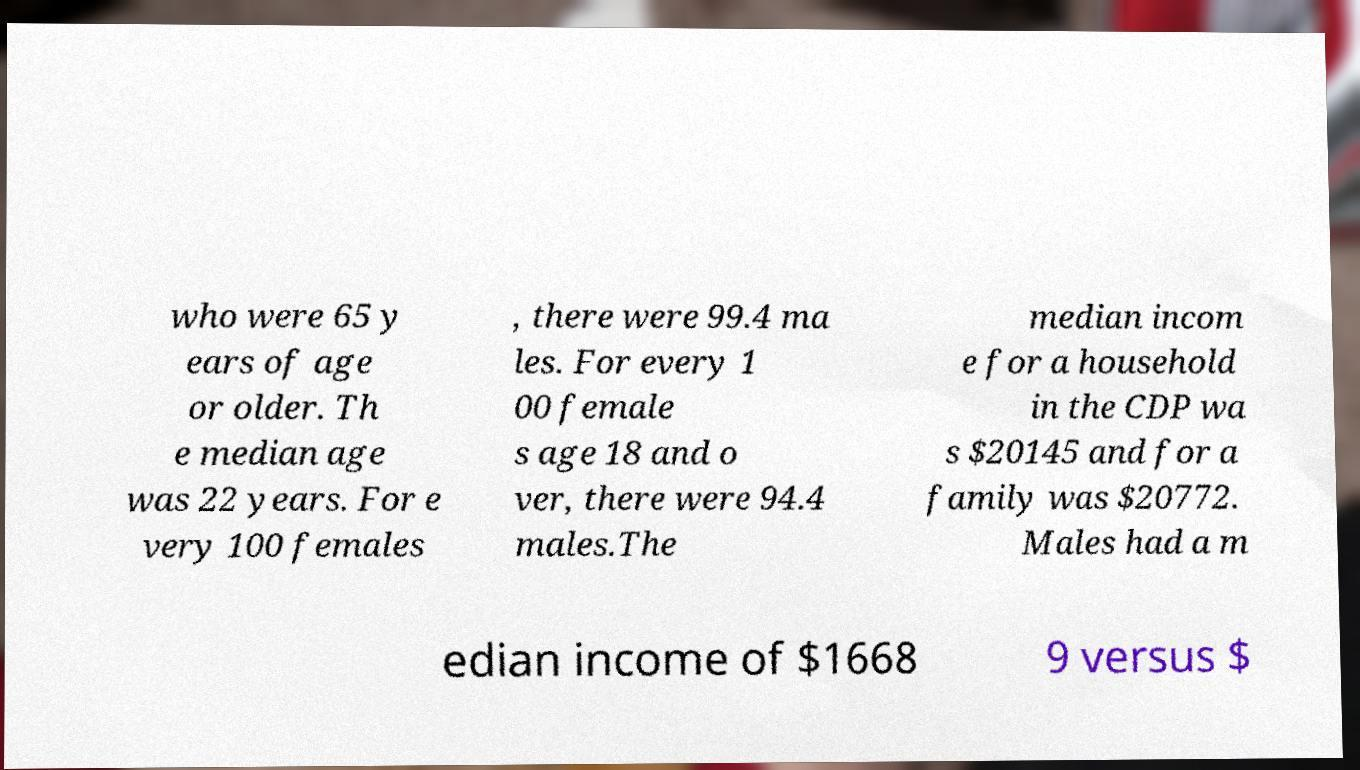I need the written content from this picture converted into text. Can you do that? who were 65 y ears of age or older. Th e median age was 22 years. For e very 100 females , there were 99.4 ma les. For every 1 00 female s age 18 and o ver, there were 94.4 males.The median incom e for a household in the CDP wa s $20145 and for a family was $20772. Males had a m edian income of $1668 9 versus $ 